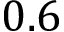<formula> <loc_0><loc_0><loc_500><loc_500>0 . 6</formula> 